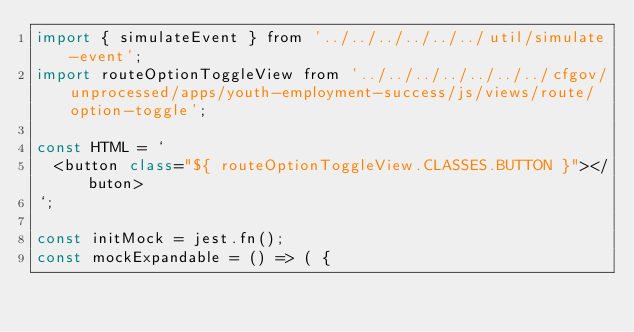Convert code to text. <code><loc_0><loc_0><loc_500><loc_500><_JavaScript_>import { simulateEvent } from '../../../../../../util/simulate-event';
import routeOptionToggleView from '../../../../../../../cfgov/unprocessed/apps/youth-employment-success/js/views/route/option-toggle';

const HTML = `
  <button class="${ routeOptionToggleView.CLASSES.BUTTON }"></buton>
`;

const initMock = jest.fn();
const mockExpandable = () => ( {</code> 